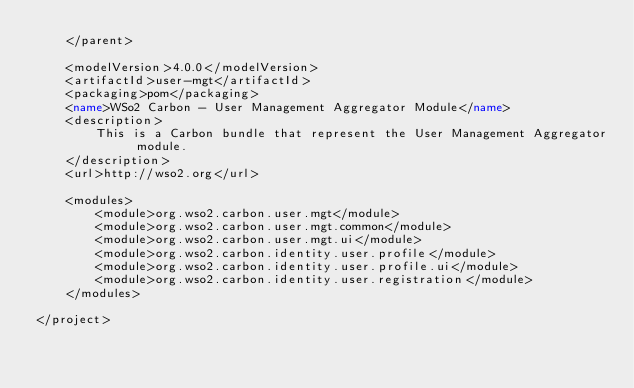<code> <loc_0><loc_0><loc_500><loc_500><_XML_>    </parent>

    <modelVersion>4.0.0</modelVersion>
    <artifactId>user-mgt</artifactId>
    <packaging>pom</packaging>
    <name>WSo2 Carbon - User Management Aggregator Module</name>
    <description>
        This is a Carbon bundle that represent the User Management Aggregator module.
    </description>
    <url>http://wso2.org</url>

    <modules>
        <module>org.wso2.carbon.user.mgt</module>
        <module>org.wso2.carbon.user.mgt.common</module>
        <module>org.wso2.carbon.user.mgt.ui</module>
        <module>org.wso2.carbon.identity.user.profile</module>
        <module>org.wso2.carbon.identity.user.profile.ui</module>
        <module>org.wso2.carbon.identity.user.registration</module>
    </modules>

</project>
</code> 